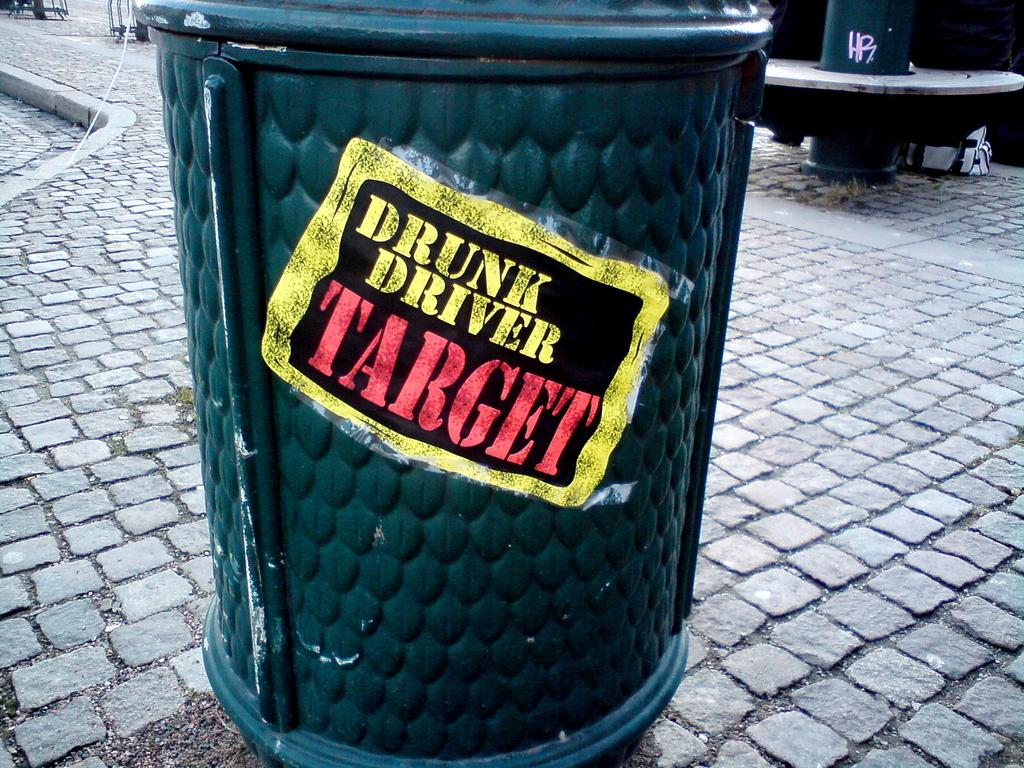What is this garbage can a target for?
Offer a terse response. Drunk driver. What is written in red?
Your response must be concise. Target. 